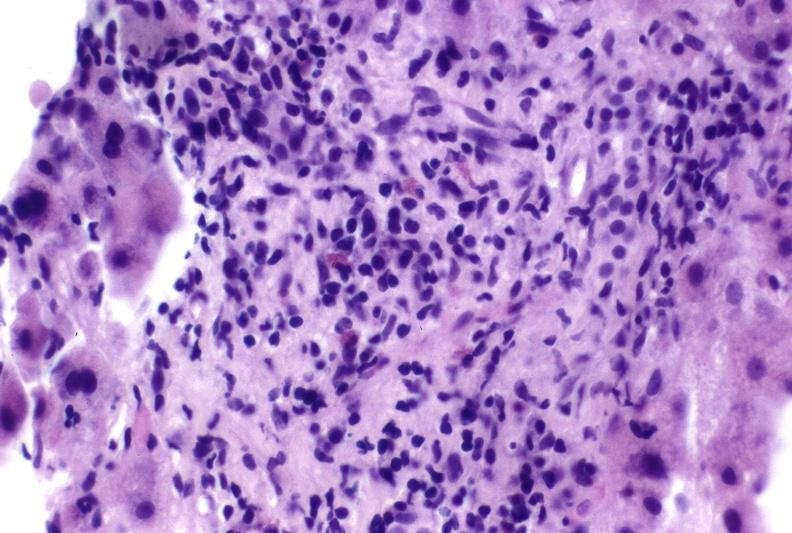s papillary adenoma present?
Answer the question using a single word or phrase. No 